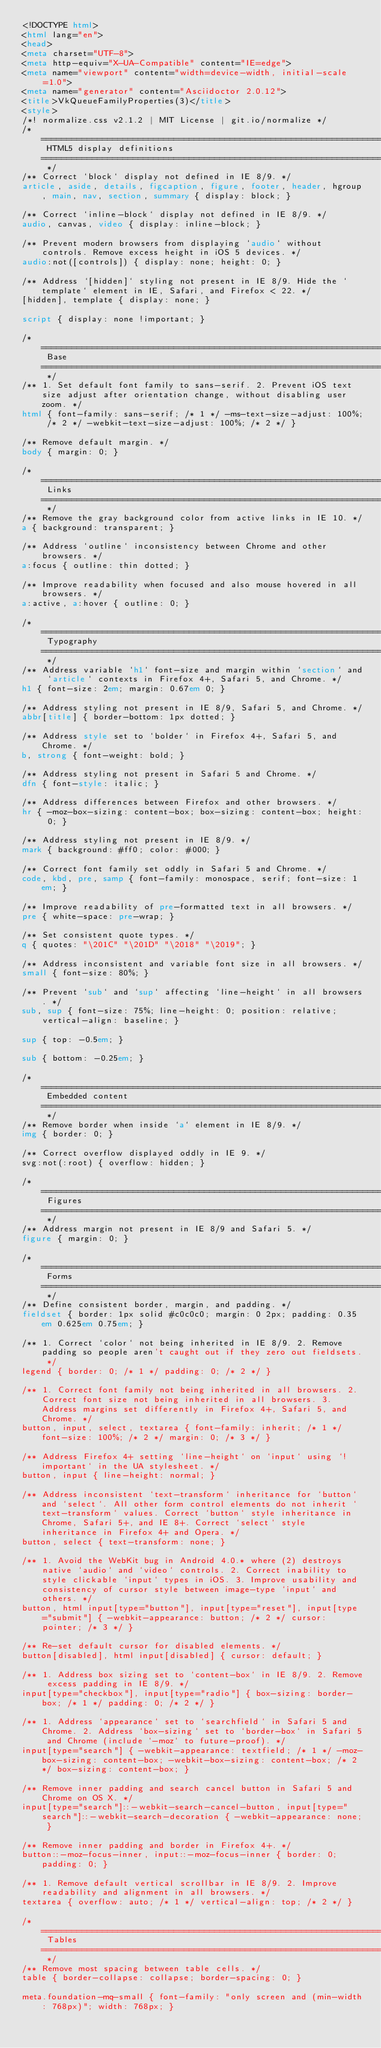Convert code to text. <code><loc_0><loc_0><loc_500><loc_500><_HTML_><!DOCTYPE html>
<html lang="en">
<head>
<meta charset="UTF-8">
<meta http-equiv="X-UA-Compatible" content="IE=edge">
<meta name="viewport" content="width=device-width, initial-scale=1.0">
<meta name="generator" content="Asciidoctor 2.0.12">
<title>VkQueueFamilyProperties(3)</title>
<style>
/*! normalize.css v2.1.2 | MIT License | git.io/normalize */
/* ========================================================================== HTML5 display definitions ========================================================================== */
/** Correct `block` display not defined in IE 8/9. */
article, aside, details, figcaption, figure, footer, header, hgroup, main, nav, section, summary { display: block; }

/** Correct `inline-block` display not defined in IE 8/9. */
audio, canvas, video { display: inline-block; }

/** Prevent modern browsers from displaying `audio` without controls. Remove excess height in iOS 5 devices. */
audio:not([controls]) { display: none; height: 0; }

/** Address `[hidden]` styling not present in IE 8/9. Hide the `template` element in IE, Safari, and Firefox < 22. */
[hidden], template { display: none; }

script { display: none !important; }

/* ========================================================================== Base ========================================================================== */
/** 1. Set default font family to sans-serif. 2. Prevent iOS text size adjust after orientation change, without disabling user zoom. */
html { font-family: sans-serif; /* 1 */ -ms-text-size-adjust: 100%; /* 2 */ -webkit-text-size-adjust: 100%; /* 2 */ }

/** Remove default margin. */
body { margin: 0; }

/* ========================================================================== Links ========================================================================== */
/** Remove the gray background color from active links in IE 10. */
a { background: transparent; }

/** Address `outline` inconsistency between Chrome and other browsers. */
a:focus { outline: thin dotted; }

/** Improve readability when focused and also mouse hovered in all browsers. */
a:active, a:hover { outline: 0; }

/* ========================================================================== Typography ========================================================================== */
/** Address variable `h1` font-size and margin within `section` and `article` contexts in Firefox 4+, Safari 5, and Chrome. */
h1 { font-size: 2em; margin: 0.67em 0; }

/** Address styling not present in IE 8/9, Safari 5, and Chrome. */
abbr[title] { border-bottom: 1px dotted; }

/** Address style set to `bolder` in Firefox 4+, Safari 5, and Chrome. */
b, strong { font-weight: bold; }

/** Address styling not present in Safari 5 and Chrome. */
dfn { font-style: italic; }

/** Address differences between Firefox and other browsers. */
hr { -moz-box-sizing: content-box; box-sizing: content-box; height: 0; }

/** Address styling not present in IE 8/9. */
mark { background: #ff0; color: #000; }

/** Correct font family set oddly in Safari 5 and Chrome. */
code, kbd, pre, samp { font-family: monospace, serif; font-size: 1em; }

/** Improve readability of pre-formatted text in all browsers. */
pre { white-space: pre-wrap; }

/** Set consistent quote types. */
q { quotes: "\201C" "\201D" "\2018" "\2019"; }

/** Address inconsistent and variable font size in all browsers. */
small { font-size: 80%; }

/** Prevent `sub` and `sup` affecting `line-height` in all browsers. */
sub, sup { font-size: 75%; line-height: 0; position: relative; vertical-align: baseline; }

sup { top: -0.5em; }

sub { bottom: -0.25em; }

/* ========================================================================== Embedded content ========================================================================== */
/** Remove border when inside `a` element in IE 8/9. */
img { border: 0; }

/** Correct overflow displayed oddly in IE 9. */
svg:not(:root) { overflow: hidden; }

/* ========================================================================== Figures ========================================================================== */
/** Address margin not present in IE 8/9 and Safari 5. */
figure { margin: 0; }

/* ========================================================================== Forms ========================================================================== */
/** Define consistent border, margin, and padding. */
fieldset { border: 1px solid #c0c0c0; margin: 0 2px; padding: 0.35em 0.625em 0.75em; }

/** 1. Correct `color` not being inherited in IE 8/9. 2. Remove padding so people aren't caught out if they zero out fieldsets. */
legend { border: 0; /* 1 */ padding: 0; /* 2 */ }

/** 1. Correct font family not being inherited in all browsers. 2. Correct font size not being inherited in all browsers. 3. Address margins set differently in Firefox 4+, Safari 5, and Chrome. */
button, input, select, textarea { font-family: inherit; /* 1 */ font-size: 100%; /* 2 */ margin: 0; /* 3 */ }

/** Address Firefox 4+ setting `line-height` on `input` using `!important` in the UA stylesheet. */
button, input { line-height: normal; }

/** Address inconsistent `text-transform` inheritance for `button` and `select`. All other form control elements do not inherit `text-transform` values. Correct `button` style inheritance in Chrome, Safari 5+, and IE 8+. Correct `select` style inheritance in Firefox 4+ and Opera. */
button, select { text-transform: none; }

/** 1. Avoid the WebKit bug in Android 4.0.* where (2) destroys native `audio` and `video` controls. 2. Correct inability to style clickable `input` types in iOS. 3. Improve usability and consistency of cursor style between image-type `input` and others. */
button, html input[type="button"], input[type="reset"], input[type="submit"] { -webkit-appearance: button; /* 2 */ cursor: pointer; /* 3 */ }

/** Re-set default cursor for disabled elements. */
button[disabled], html input[disabled] { cursor: default; }

/** 1. Address box sizing set to `content-box` in IE 8/9. 2. Remove excess padding in IE 8/9. */
input[type="checkbox"], input[type="radio"] { box-sizing: border-box; /* 1 */ padding: 0; /* 2 */ }

/** 1. Address `appearance` set to `searchfield` in Safari 5 and Chrome. 2. Address `box-sizing` set to `border-box` in Safari 5 and Chrome (include `-moz` to future-proof). */
input[type="search"] { -webkit-appearance: textfield; /* 1 */ -moz-box-sizing: content-box; -webkit-box-sizing: content-box; /* 2 */ box-sizing: content-box; }

/** Remove inner padding and search cancel button in Safari 5 and Chrome on OS X. */
input[type="search"]::-webkit-search-cancel-button, input[type="search"]::-webkit-search-decoration { -webkit-appearance: none; }

/** Remove inner padding and border in Firefox 4+. */
button::-moz-focus-inner, input::-moz-focus-inner { border: 0; padding: 0; }

/** 1. Remove default vertical scrollbar in IE 8/9. 2. Improve readability and alignment in all browsers. */
textarea { overflow: auto; /* 1 */ vertical-align: top; /* 2 */ }

/* ========================================================================== Tables ========================================================================== */
/** Remove most spacing between table cells. */
table { border-collapse: collapse; border-spacing: 0; }

meta.foundation-mq-small { font-family: "only screen and (min-width: 768px)"; width: 768px; }
</code> 